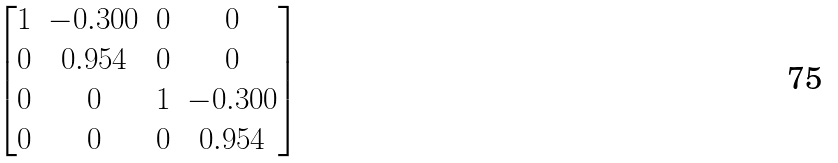<formula> <loc_0><loc_0><loc_500><loc_500>\begin{bmatrix} 1 & - 0 . 3 0 0 & 0 & 0 \\ 0 & 0 . 9 5 4 & 0 & 0 \\ 0 & 0 & 1 & - 0 . 3 0 0 \\ 0 & 0 & 0 & 0 . 9 5 4 \end{bmatrix}</formula> 